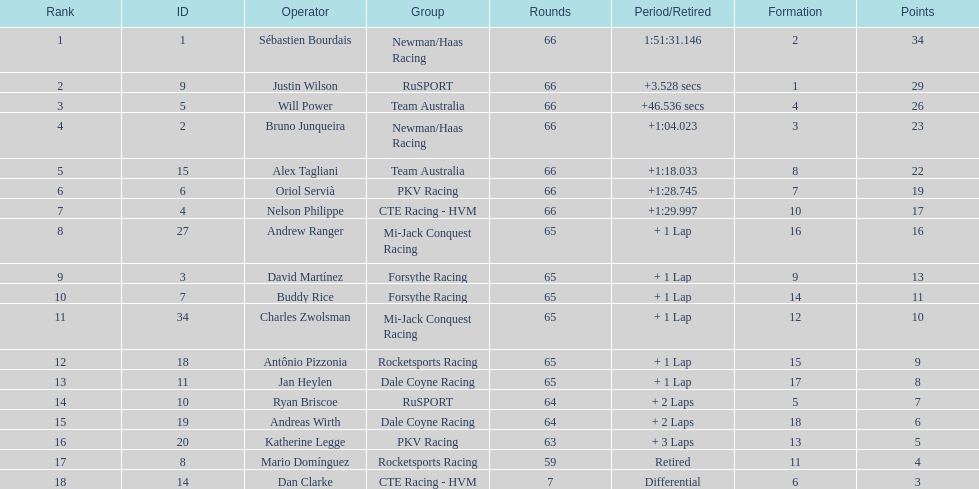At the 2006 gran premio telmex, how many drivers completed less than 60 laps? 2. 